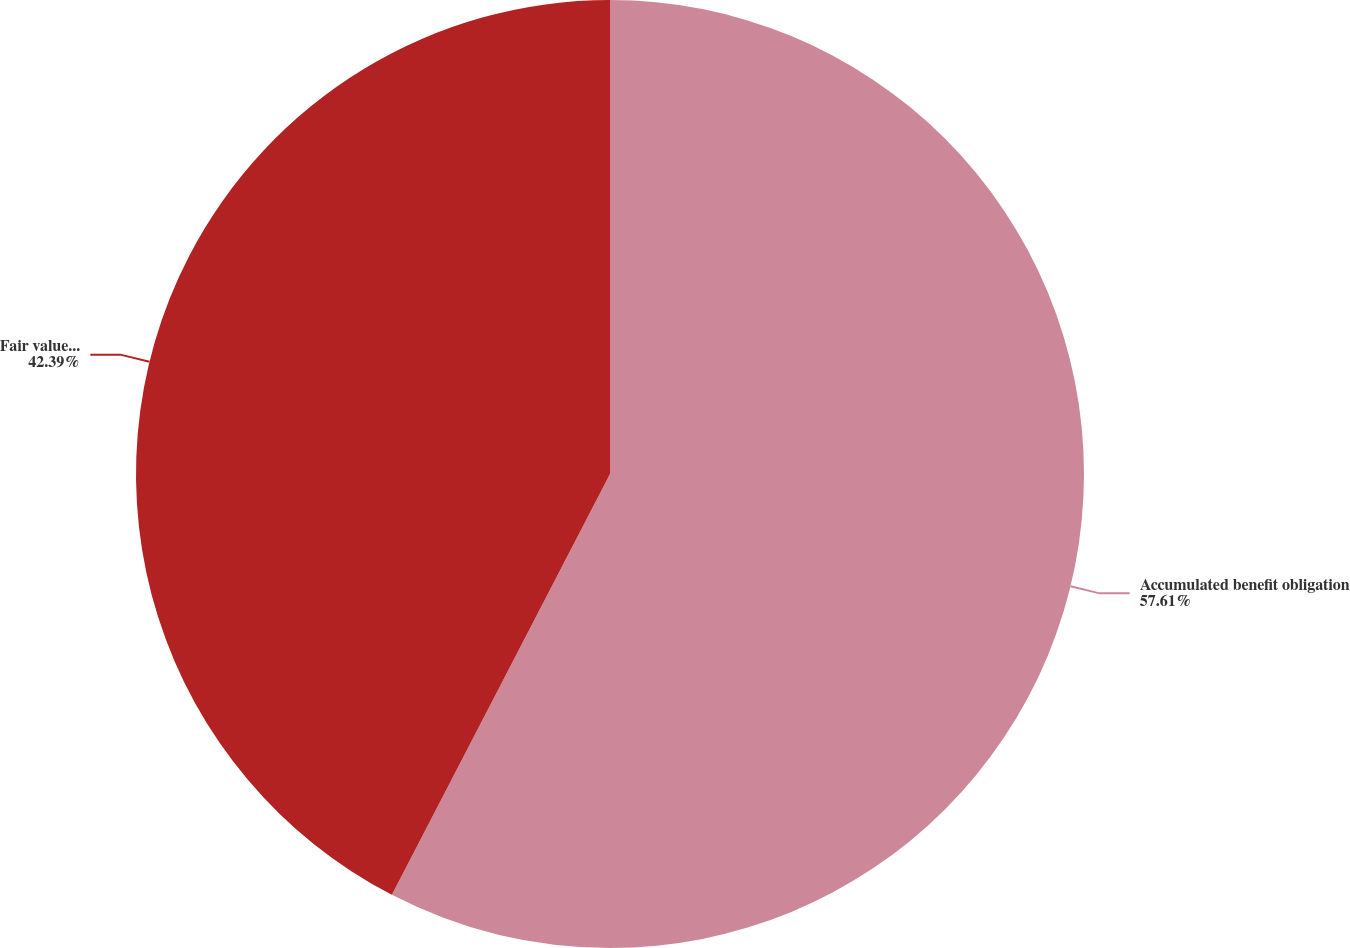Convert chart to OTSL. <chart><loc_0><loc_0><loc_500><loc_500><pie_chart><fcel>Accumulated benefit obligation<fcel>Fair value of plan assets<nl><fcel>57.61%<fcel>42.39%<nl></chart> 